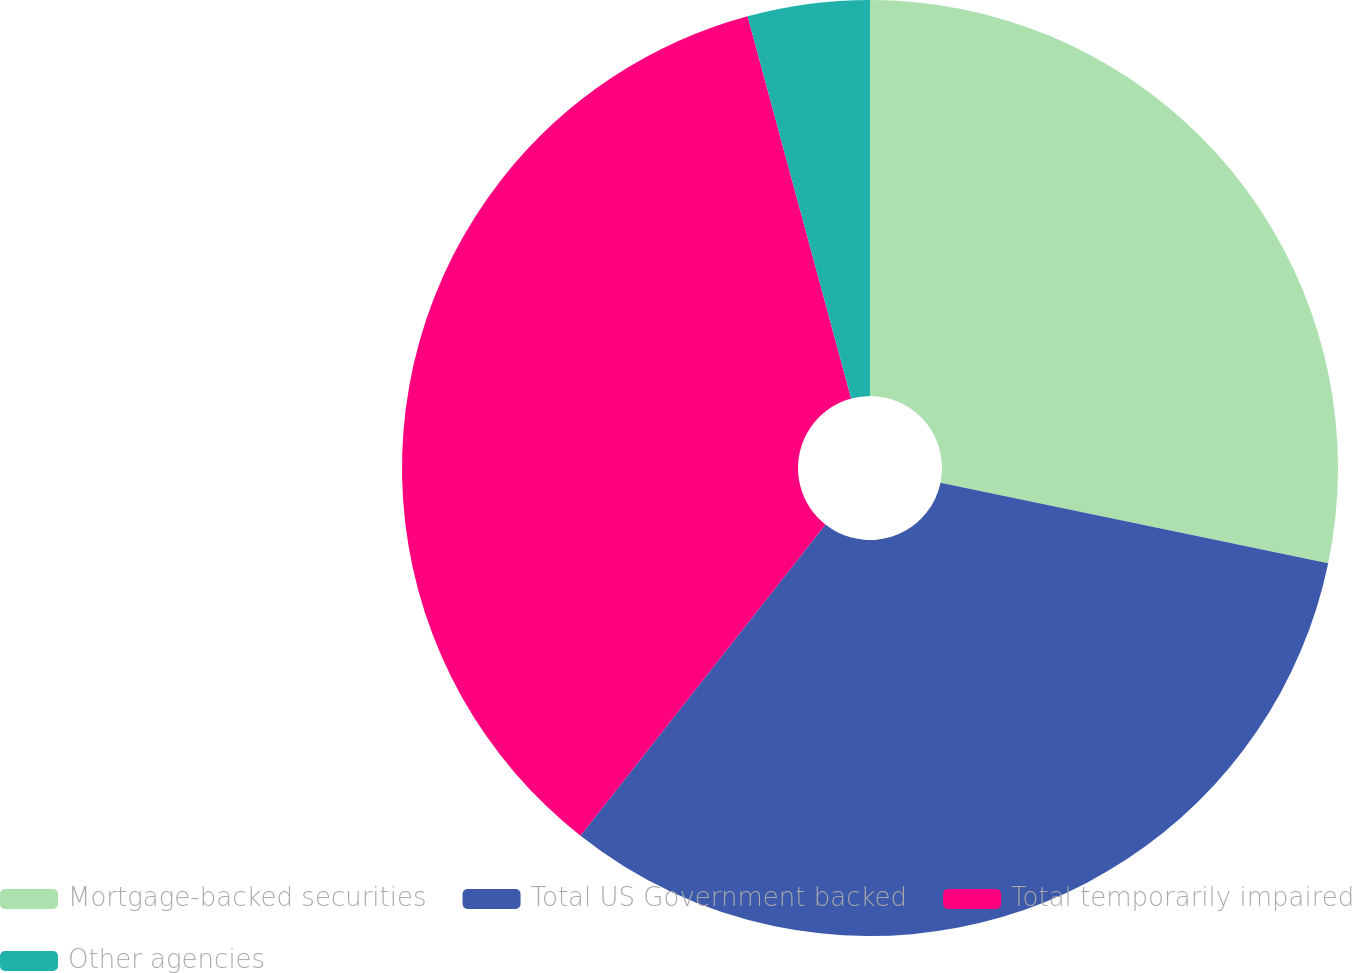Convert chart to OTSL. <chart><loc_0><loc_0><loc_500><loc_500><pie_chart><fcel>Mortgage-backed securities<fcel>Total US Government backed<fcel>Total temporarily impaired<fcel>Other agencies<nl><fcel>28.26%<fcel>32.35%<fcel>35.17%<fcel>4.21%<nl></chart> 